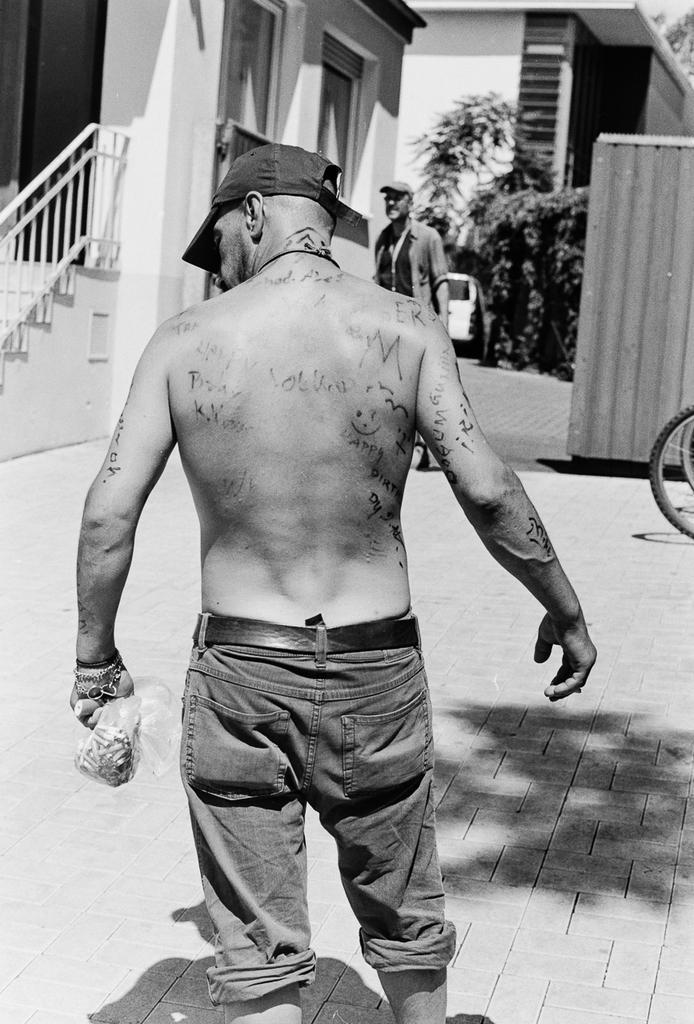How would you summarize this image in a sentence or two? This is a black and white image. There are a few people. We can see the ground with some objects. We can see some stairs and the railing. We can also see some houses and plants. We can also see some objects on the right. 